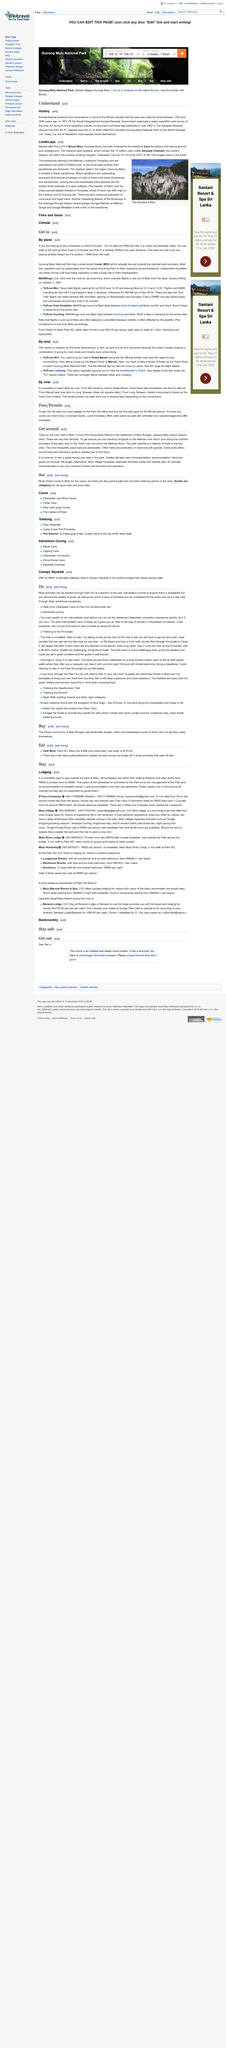Draw attention to some important aspects in this diagram. Gunung Mulu Park is famous for its limestone karst formations, both above ground and underground. The park is known for its unique and stunning geological features, such as caves, cliffs, and pinnacles, which have been formed over thousands of years by the erosion of limestone rock. These formations create a breathtaking landscape that attracts visitors from around the world. In 1977-78, the Royal Geographical Society, in collaboration with the Sarawak Government, organized and conducted a major expedition and survey of the area. Clearwater Cave is the 10th longest cave in the world. 